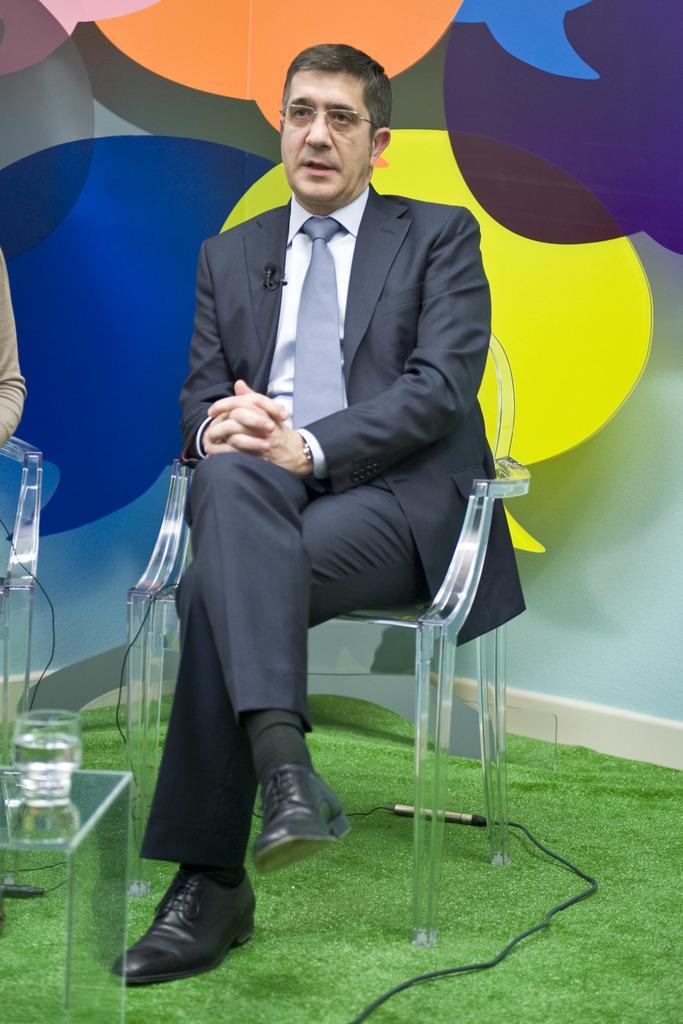In one or two sentences, can you explain what this image depicts? In this picture a man is sitting on the chair with a colorful background. 